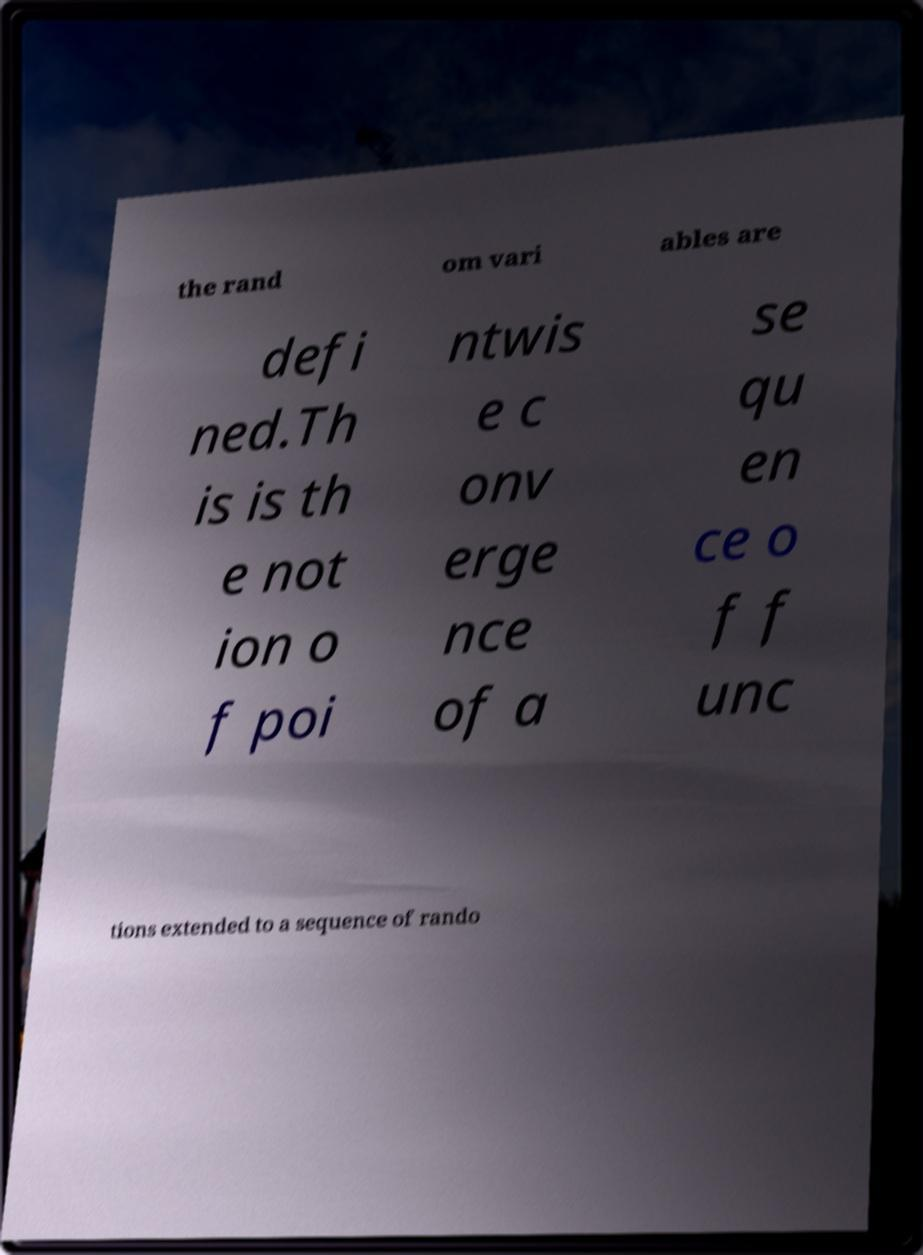Can you read and provide the text displayed in the image?This photo seems to have some interesting text. Can you extract and type it out for me? the rand om vari ables are defi ned.Th is is th e not ion o f poi ntwis e c onv erge nce of a se qu en ce o f f unc tions extended to a sequence of rando 